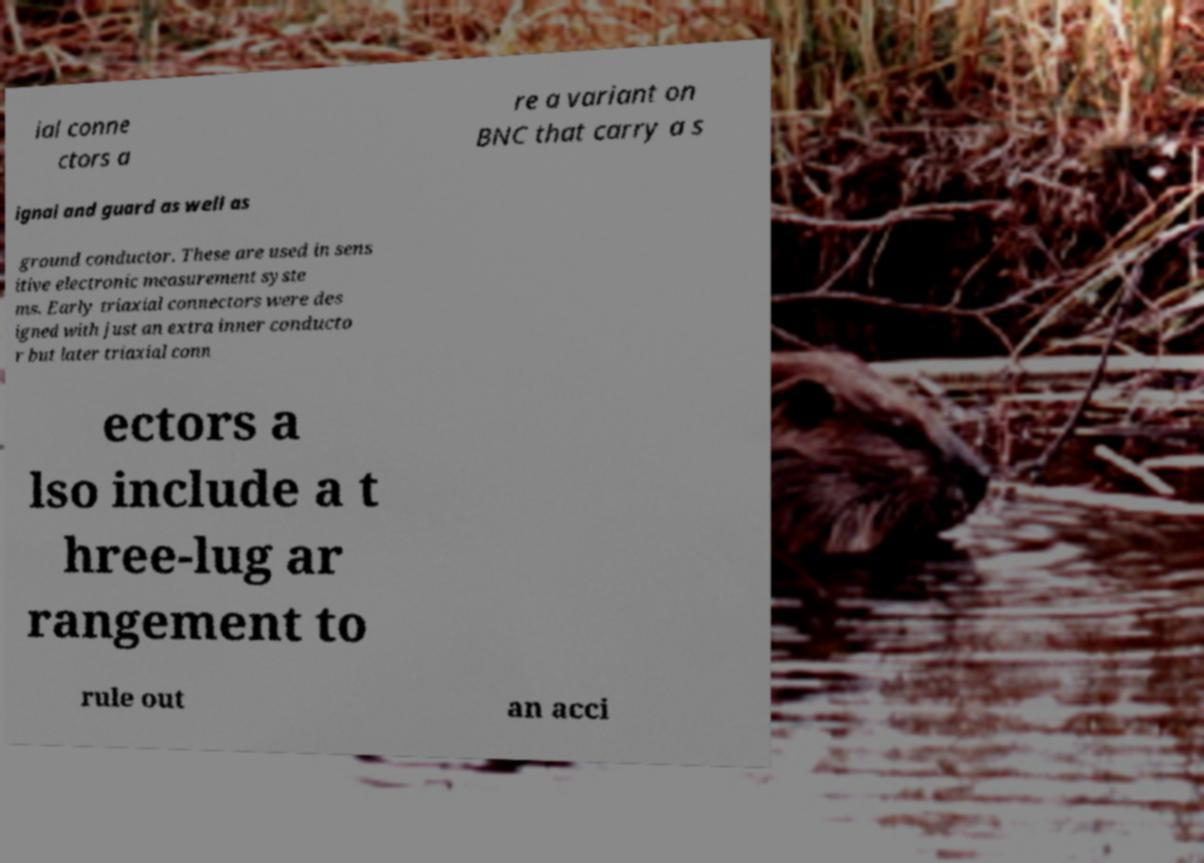Can you read and provide the text displayed in the image?This photo seems to have some interesting text. Can you extract and type it out for me? ial conne ctors a re a variant on BNC that carry a s ignal and guard as well as ground conductor. These are used in sens itive electronic measurement syste ms. Early triaxial connectors were des igned with just an extra inner conducto r but later triaxial conn ectors a lso include a t hree-lug ar rangement to rule out an acci 